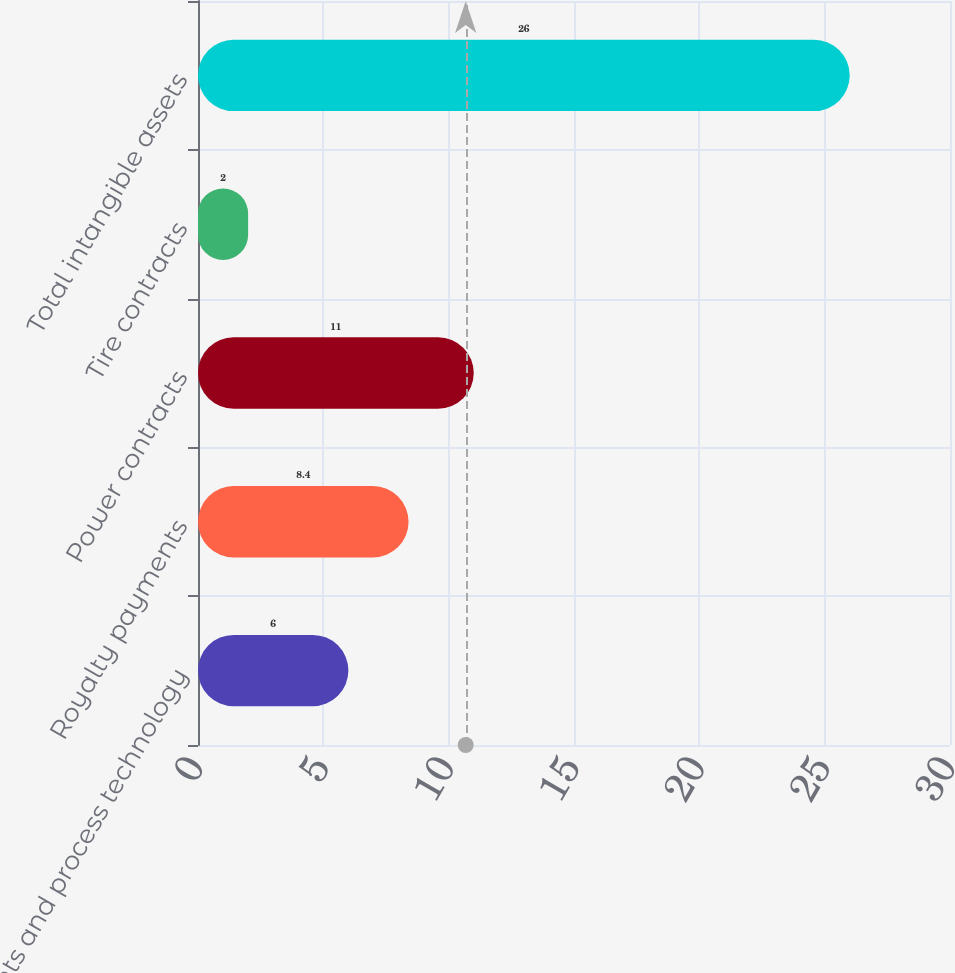Convert chart to OTSL. <chart><loc_0><loc_0><loc_500><loc_500><bar_chart><fcel>Patents and process technology<fcel>Royalty payments<fcel>Power contracts<fcel>Tire contracts<fcel>Total intangible assets<nl><fcel>6<fcel>8.4<fcel>11<fcel>2<fcel>26<nl></chart> 